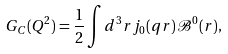Convert formula to latex. <formula><loc_0><loc_0><loc_500><loc_500>G _ { C } ( Q ^ { 2 } ) = \frac { 1 } { 2 } \int d ^ { 3 } r j _ { 0 } ( q r ) \mathcal { B } ^ { 0 } ( r ) ,</formula> 